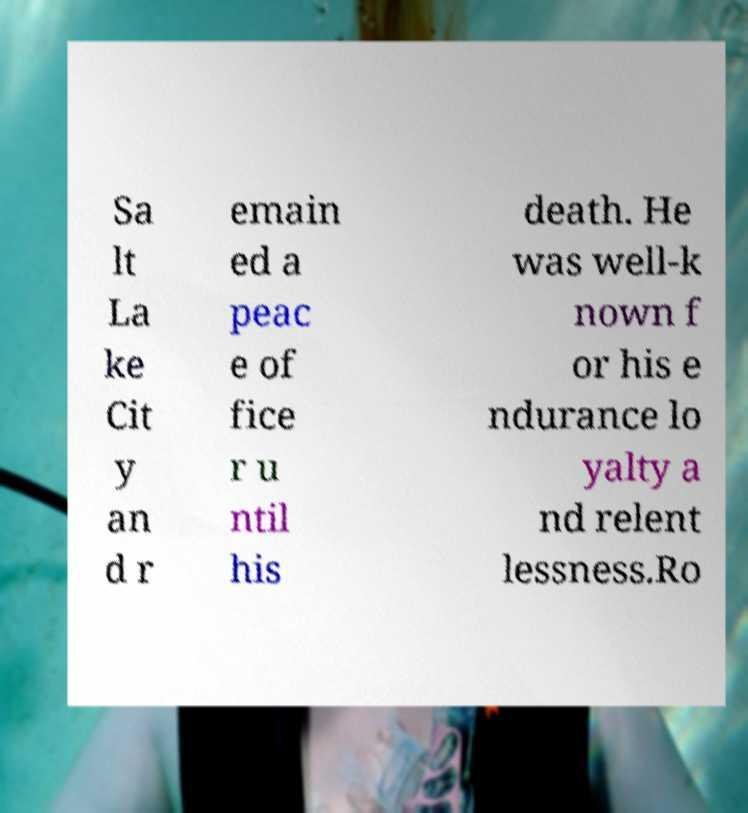Please read and relay the text visible in this image. What does it say? Sa lt La ke Cit y an d r emain ed a peac e of fice r u ntil his death. He was well-k nown f or his e ndurance lo yalty a nd relent lessness.Ro 